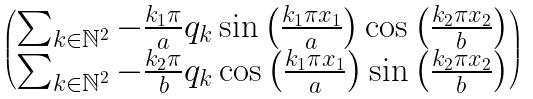Convert formula to latex. <formula><loc_0><loc_0><loc_500><loc_500>\begin{pmatrix} \sum _ { k \in \mathbb { N } ^ { 2 } } - \frac { k _ { 1 } \pi } { a } q _ { k } \sin \left ( \frac { k _ { 1 } \pi x _ { 1 } } { a } \right ) \cos \left ( \frac { k _ { 2 } \pi x _ { 2 } } { b } \right ) \\ \sum _ { k \in \mathbb { N } ^ { 2 } } - \frac { k _ { 2 } \pi } { b } q _ { k } \cos \left ( \frac { k _ { 1 } \pi x _ { 1 } } { a } \right ) \sin \left ( \frac { k _ { 2 } \pi x _ { 2 } } { b } \right ) \end{pmatrix}</formula> 